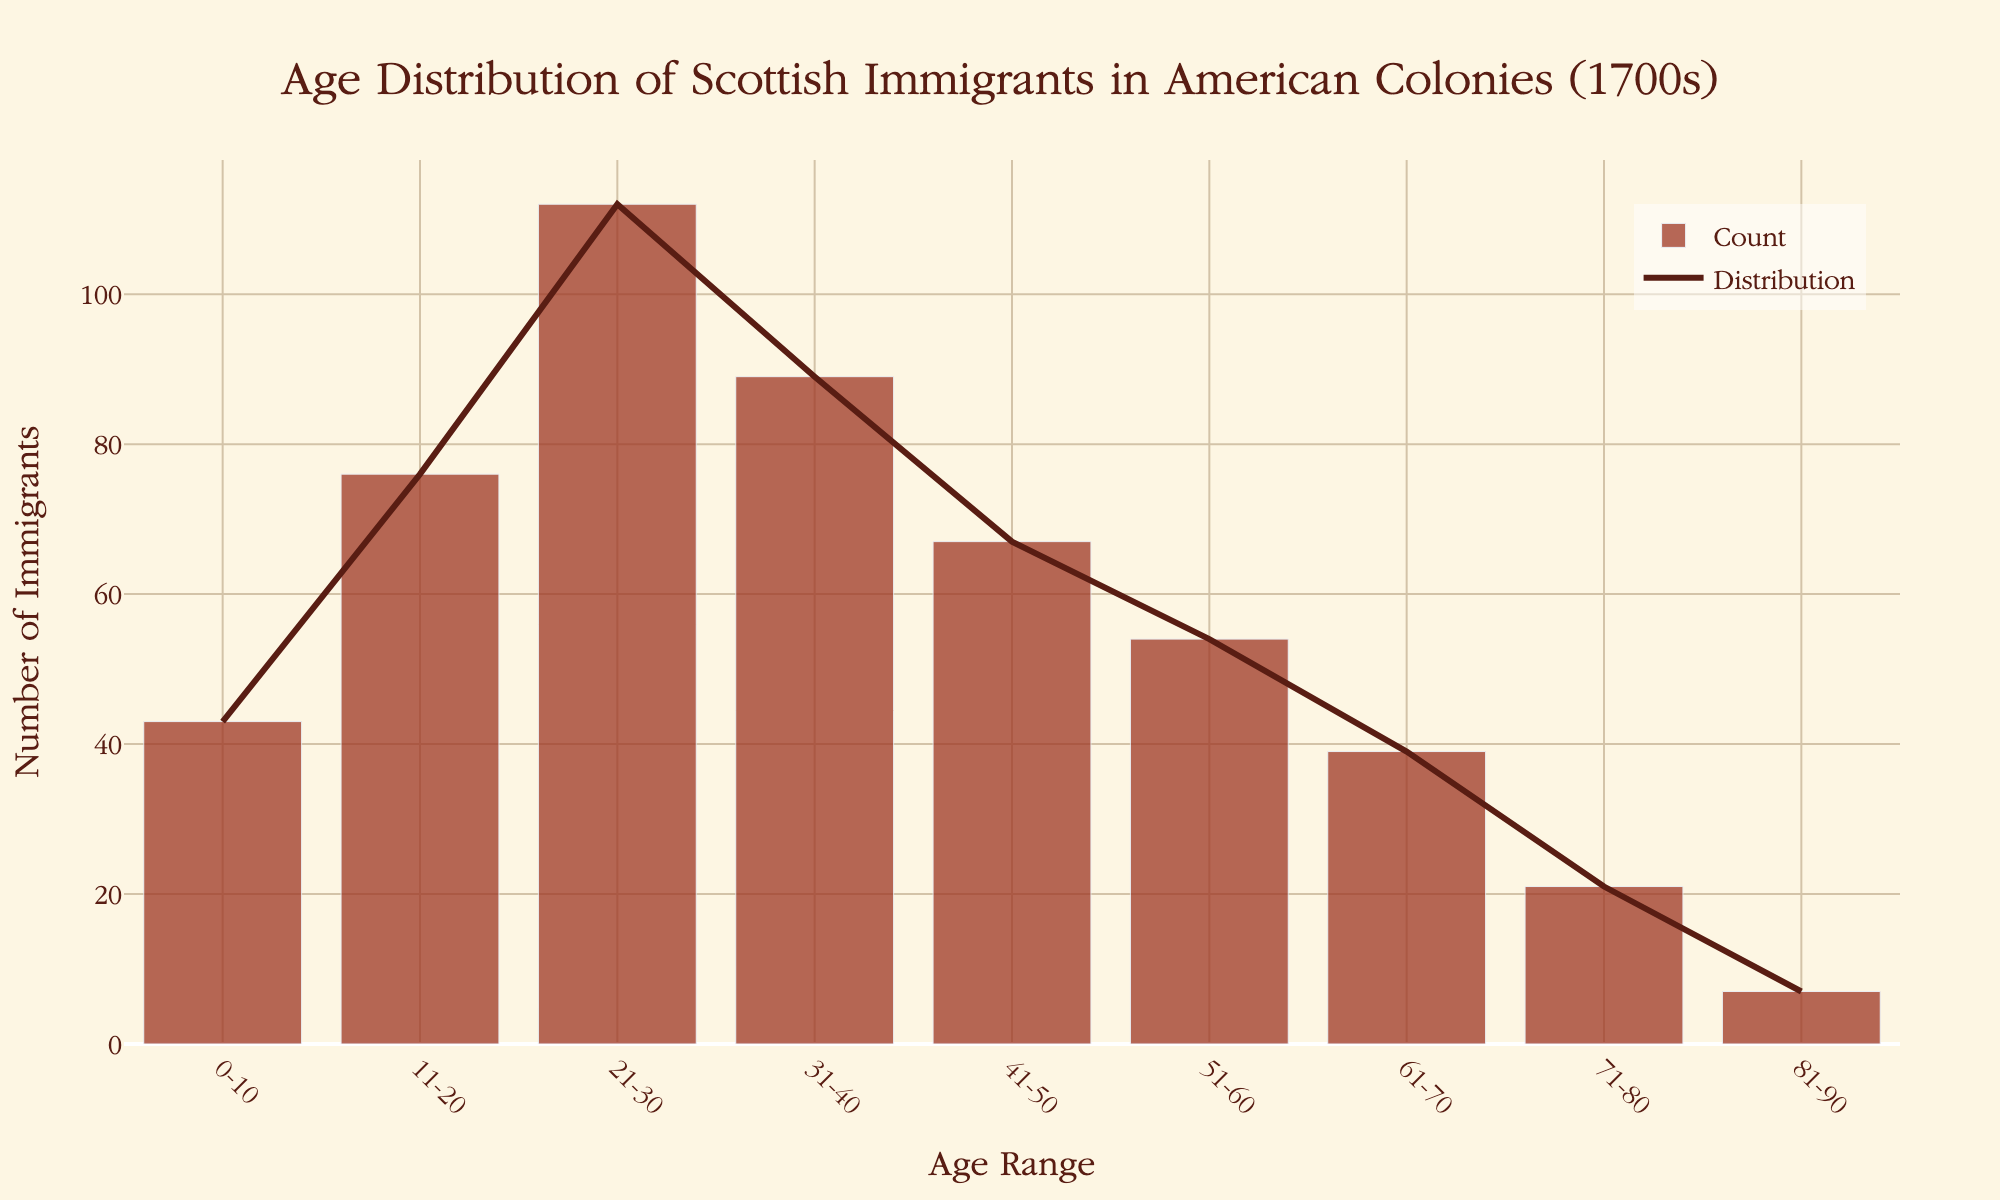what is the most common age range? The highest bar represents the age range with the most immigrants. The '21-30' age range has the highest count, which is 112.
Answer: 21-30 How many age ranges are represented in the figure? Count the distinct age ranges listed along the x-axis. There are 9 distinct age ranges displayed.
Answer: 9 Which age range has the least number of immigrants? Identify the shortest bar which indicates the age range with the least count. The '81-90' age range has the least number of immigrants, with a count of 7.
Answer: 81-90 What is the total number of immigrants represented in the figure? Sum the counts of all age ranges: 43 + 76 + 112 + 89 + 67 + 54 + 39 + 21 + 7 = 508.
Answer: 508 What is the difference in the number of immigrants between the '21-30' and '31-40' age ranges? Calculate the difference in the counts: 112 - 89 = 23.
Answer: 23 Which two consecutive age ranges have the largest drop in the number of immigrants? Find the largest decrease between any two consecutive age ranges: The difference between '21-30' (112) and '31-40' (89) is 23, which is the largest drop.
Answer: '21-30' to '31-40' What is the average number of immigrants per age range? Divide the total number of immigrants by the number of age ranges: 508 immigrants / 9 age ranges = approximately 56.4 immigrants per range.
Answer: 56.4 Which age ranges have more than 50 immigrants? Identify all the age ranges with counts greater than 50: '11-20' (76), '21-30' (112), '31-40' (89), and '41-50' (67).
Answer: '11-20', '21-30', '31-40', '41-50' What is the color used for the bars representing the count? By referring to the visual description, the bars are depicted in a reddish-brown color.
Answer: reddish-brown 